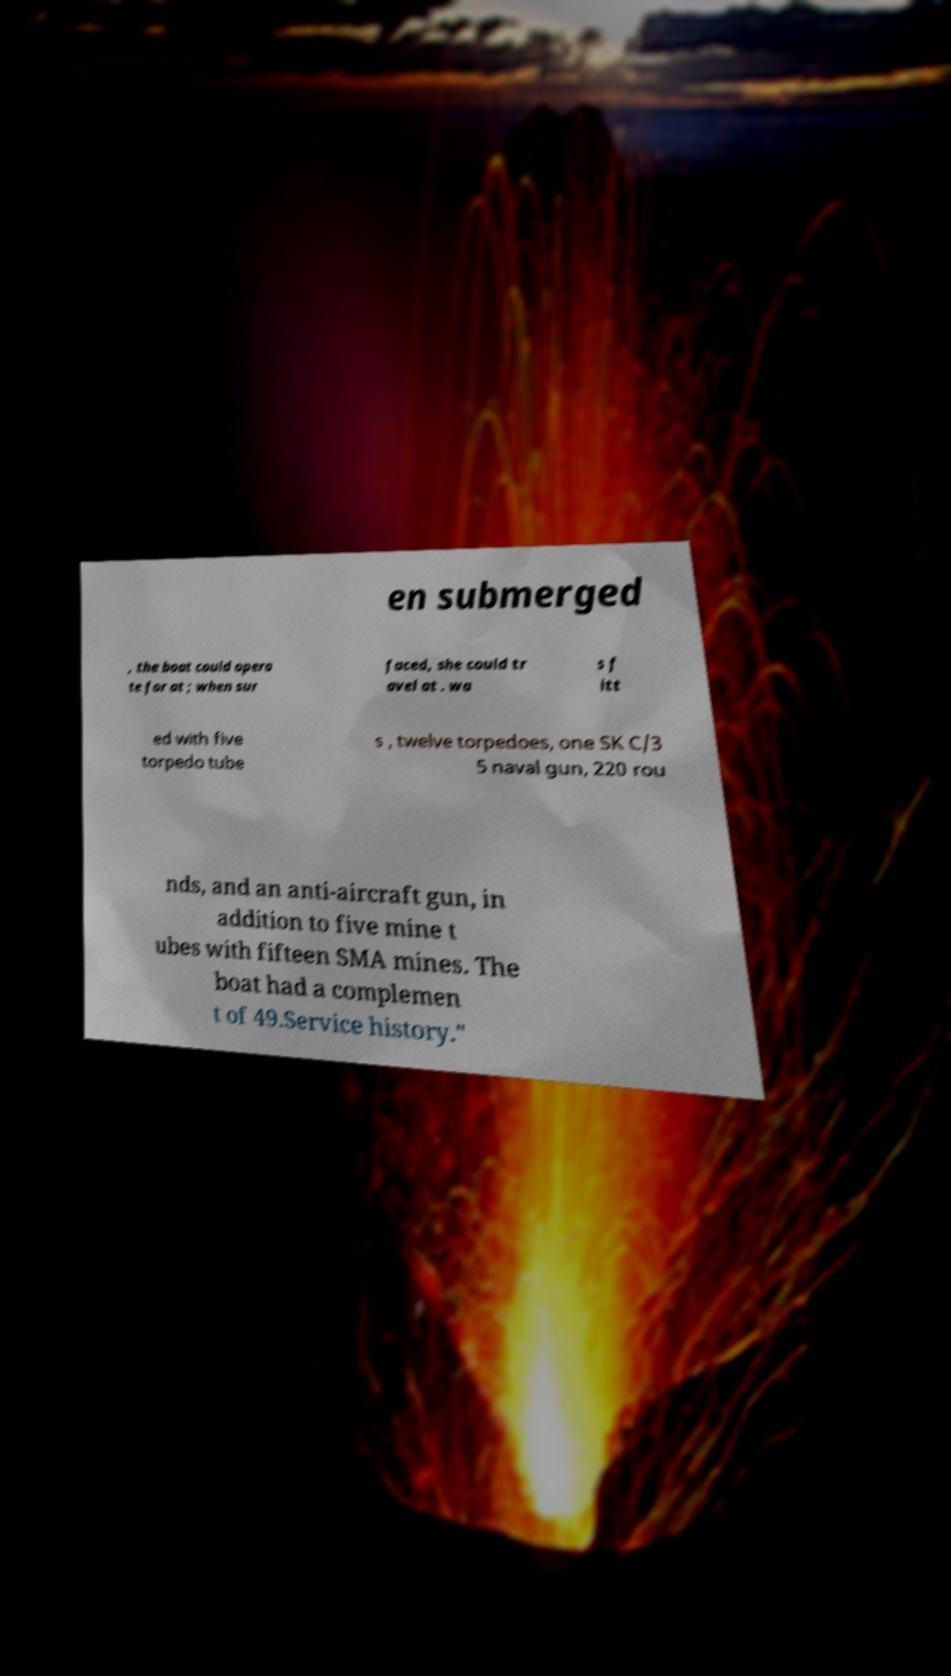For documentation purposes, I need the text within this image transcribed. Could you provide that? en submerged , the boat could opera te for at ; when sur faced, she could tr avel at . wa s f itt ed with five torpedo tube s , twelve torpedoes, one SK C/3 5 naval gun, 220 rou nds, and an anti-aircraft gun, in addition to five mine t ubes with fifteen SMA mines. The boat had a complemen t of 49.Service history." 